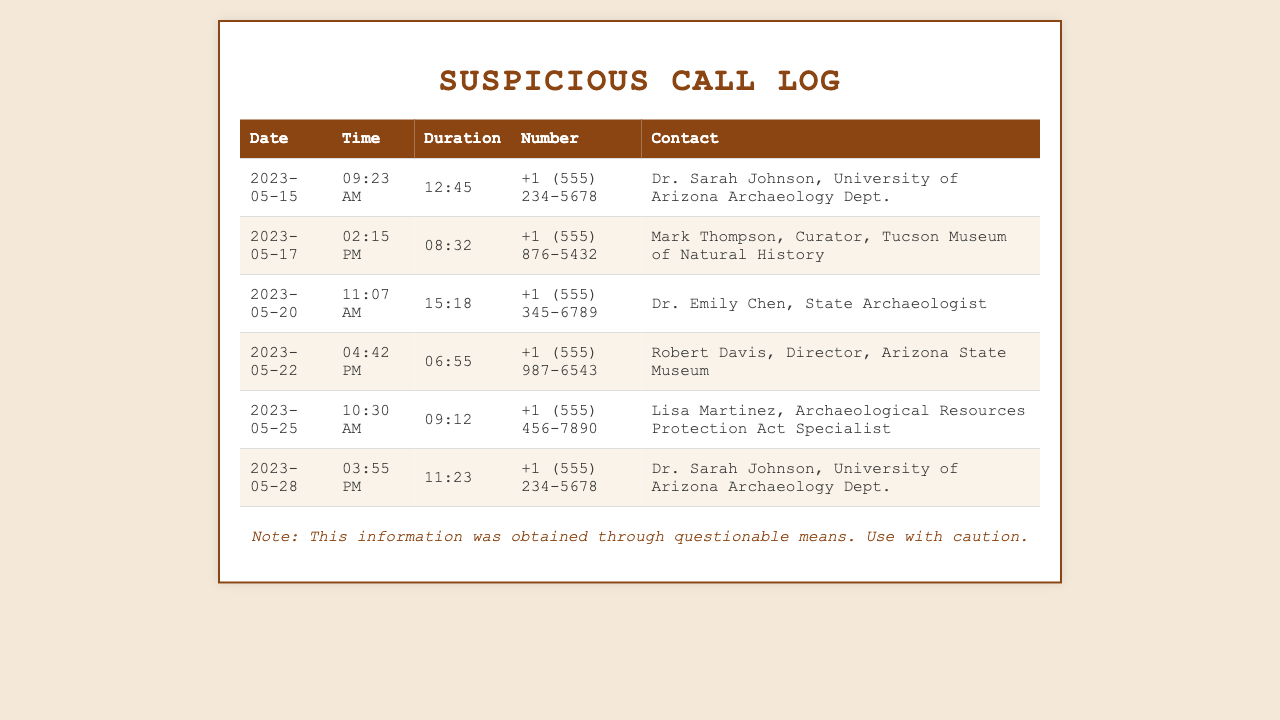what is the date of the longest call? The longest call is on May 20, lasting 15 minutes and 18 seconds.
Answer: 2023-05-20 who was called on May 22? On May 22, the call was made to Robert Davis, Director, Arizona State Museum.
Answer: Robert Davis what is the contact number for Dr. Sarah Johnson? Dr. Sarah Johnson's contact number appears twice as +1 (555) 234-5678.
Answer: +1 (555) 234-5678 how many calls were made to local archaeologists? There are four calls to local archaeologists in the document.
Answer: 4 who is the longest caller based on the total duration of calls? The caller with the highest total duration is Dr. Sarah Johnson.
Answer: Dr. Sarah Johnson what title does Lisa Martinez hold? Lisa Martinez is an Archaeological Resources Protection Act Specialist.
Answer: Archaeological Resources Protection Act Specialist which organization is Mark Thompson affiliated with? Mark Thompson is the Curator at the Tucson Museum of Natural History.
Answer: Tucson Museum of Natural History what is the average duration of the calls listed? The average duration can be calculated by summing up the durations and dividing by the number of calls. The total duration is 53:42 across six calls, resulting in an average of approximately 8 minutes and 57 seconds.
Answer: 8:57 